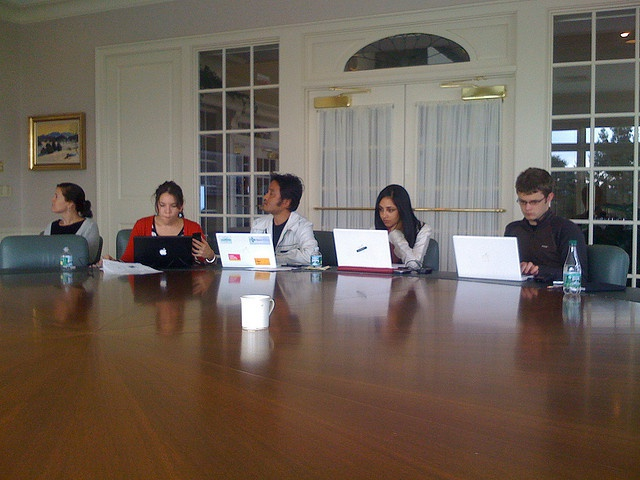Describe the objects in this image and their specific colors. I can see people in darkgreen, black, and gray tones, people in darkgreen, black, gray, and maroon tones, people in darkgreen, darkgray, black, lightgray, and brown tones, people in darkgreen, black, darkgray, brown, and gray tones, and laptop in darkgreen, lavender, darkgray, and gray tones in this image. 